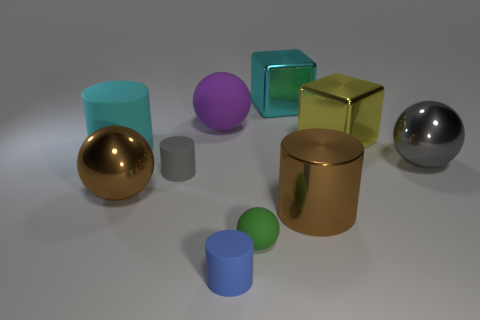Subtract 1 cylinders. How many cylinders are left? 3 Subtract all balls. How many objects are left? 6 Add 8 large cyan matte balls. How many large cyan matte balls exist? 8 Subtract 0 green cylinders. How many objects are left? 10 Subtract all tiny balls. Subtract all brown balls. How many objects are left? 8 Add 5 rubber cylinders. How many rubber cylinders are left? 8 